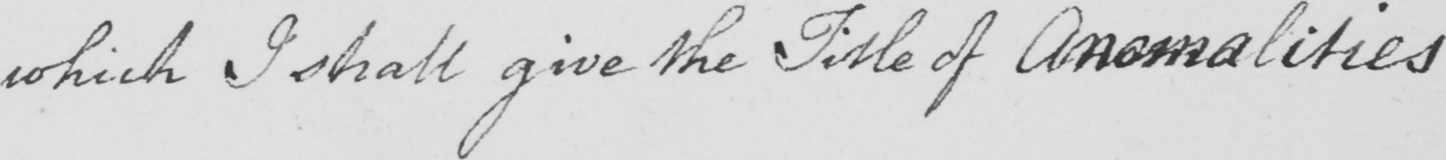Please provide the text content of this handwritten line. which I shall give the Title of Anomalities 